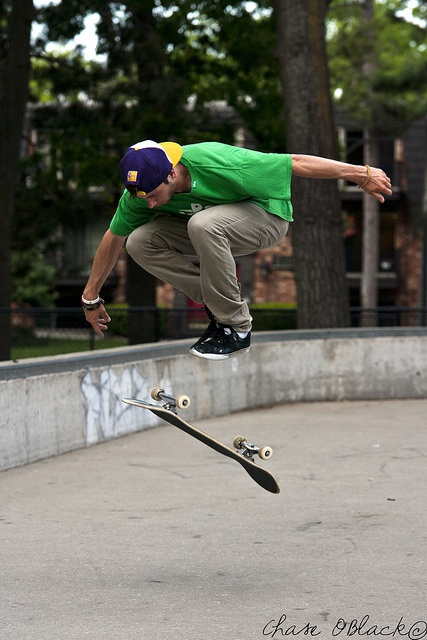Describe the objects in this image and their specific colors. I can see people in black, gray, maroon, and darkgreen tones and skateboard in black, darkgray, gray, and lightgray tones in this image. 